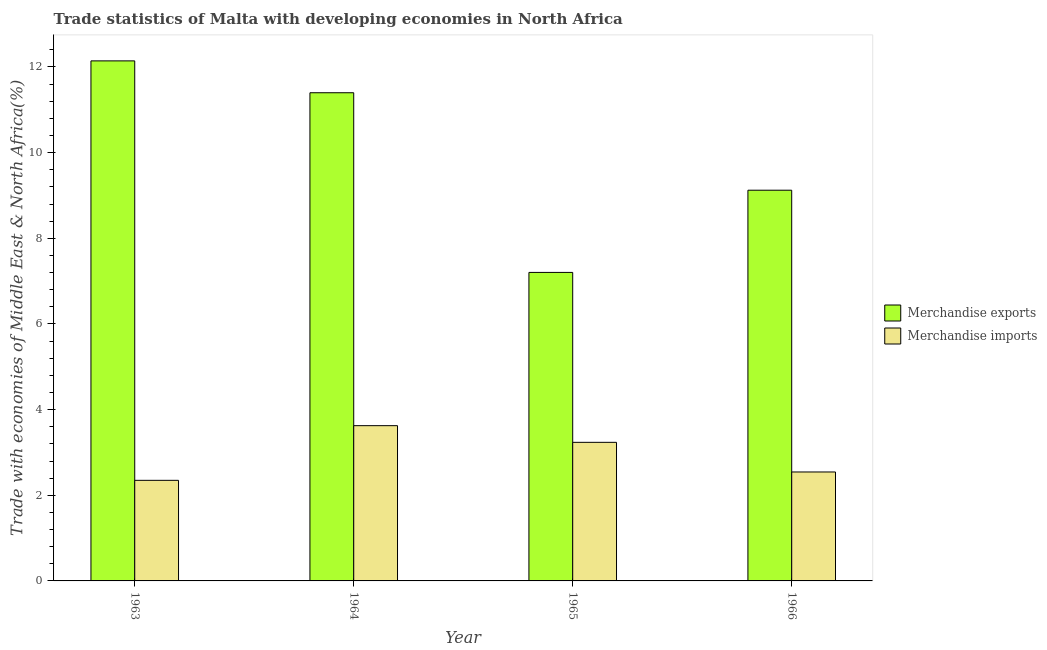How many different coloured bars are there?
Provide a succinct answer. 2. How many groups of bars are there?
Ensure brevity in your answer.  4. Are the number of bars per tick equal to the number of legend labels?
Your answer should be compact. Yes. Are the number of bars on each tick of the X-axis equal?
Offer a very short reply. Yes. How many bars are there on the 2nd tick from the right?
Give a very brief answer. 2. What is the label of the 2nd group of bars from the left?
Your answer should be compact. 1964. In how many cases, is the number of bars for a given year not equal to the number of legend labels?
Offer a very short reply. 0. What is the merchandise imports in 1965?
Offer a very short reply. 3.24. Across all years, what is the maximum merchandise imports?
Provide a short and direct response. 3.63. Across all years, what is the minimum merchandise imports?
Make the answer very short. 2.35. In which year was the merchandise imports maximum?
Your response must be concise. 1964. In which year was the merchandise exports minimum?
Your answer should be very brief. 1965. What is the total merchandise exports in the graph?
Your answer should be compact. 39.87. What is the difference between the merchandise imports in 1965 and that in 1966?
Make the answer very short. 0.69. What is the difference between the merchandise imports in 1965 and the merchandise exports in 1966?
Offer a terse response. 0.69. What is the average merchandise imports per year?
Ensure brevity in your answer.  2.94. In how many years, is the merchandise imports greater than 9.2 %?
Your response must be concise. 0. What is the ratio of the merchandise imports in 1965 to that in 1966?
Offer a terse response. 1.27. Is the difference between the merchandise exports in 1964 and 1966 greater than the difference between the merchandise imports in 1964 and 1966?
Your response must be concise. No. What is the difference between the highest and the second highest merchandise imports?
Your answer should be very brief. 0.39. What is the difference between the highest and the lowest merchandise imports?
Offer a very short reply. 1.28. In how many years, is the merchandise exports greater than the average merchandise exports taken over all years?
Offer a terse response. 2. Is the sum of the merchandise imports in 1964 and 1965 greater than the maximum merchandise exports across all years?
Give a very brief answer. Yes. What does the 2nd bar from the left in 1963 represents?
Ensure brevity in your answer.  Merchandise imports. How many bars are there?
Offer a terse response. 8. Are all the bars in the graph horizontal?
Offer a terse response. No. How many years are there in the graph?
Keep it short and to the point. 4. Does the graph contain any zero values?
Your response must be concise. No. Does the graph contain grids?
Your answer should be very brief. No. How many legend labels are there?
Offer a very short reply. 2. What is the title of the graph?
Your answer should be compact. Trade statistics of Malta with developing economies in North Africa. Does "Lower secondary education" appear as one of the legend labels in the graph?
Provide a short and direct response. No. What is the label or title of the Y-axis?
Your response must be concise. Trade with economies of Middle East & North Africa(%). What is the Trade with economies of Middle East & North Africa(%) in Merchandise exports in 1963?
Keep it short and to the point. 12.14. What is the Trade with economies of Middle East & North Africa(%) of Merchandise imports in 1963?
Keep it short and to the point. 2.35. What is the Trade with economies of Middle East & North Africa(%) in Merchandise exports in 1964?
Offer a terse response. 11.4. What is the Trade with economies of Middle East & North Africa(%) of Merchandise imports in 1964?
Provide a succinct answer. 3.63. What is the Trade with economies of Middle East & North Africa(%) in Merchandise exports in 1965?
Your answer should be very brief. 7.2. What is the Trade with economies of Middle East & North Africa(%) in Merchandise imports in 1965?
Provide a succinct answer. 3.24. What is the Trade with economies of Middle East & North Africa(%) in Merchandise exports in 1966?
Make the answer very short. 9.12. What is the Trade with economies of Middle East & North Africa(%) of Merchandise imports in 1966?
Make the answer very short. 2.54. Across all years, what is the maximum Trade with economies of Middle East & North Africa(%) of Merchandise exports?
Make the answer very short. 12.14. Across all years, what is the maximum Trade with economies of Middle East & North Africa(%) in Merchandise imports?
Give a very brief answer. 3.63. Across all years, what is the minimum Trade with economies of Middle East & North Africa(%) of Merchandise exports?
Offer a very short reply. 7.2. Across all years, what is the minimum Trade with economies of Middle East & North Africa(%) in Merchandise imports?
Offer a terse response. 2.35. What is the total Trade with economies of Middle East & North Africa(%) of Merchandise exports in the graph?
Offer a terse response. 39.87. What is the total Trade with economies of Middle East & North Africa(%) in Merchandise imports in the graph?
Give a very brief answer. 11.75. What is the difference between the Trade with economies of Middle East & North Africa(%) in Merchandise exports in 1963 and that in 1964?
Provide a succinct answer. 0.74. What is the difference between the Trade with economies of Middle East & North Africa(%) of Merchandise imports in 1963 and that in 1964?
Make the answer very short. -1.28. What is the difference between the Trade with economies of Middle East & North Africa(%) of Merchandise exports in 1963 and that in 1965?
Your response must be concise. 4.94. What is the difference between the Trade with economies of Middle East & North Africa(%) of Merchandise imports in 1963 and that in 1965?
Offer a terse response. -0.89. What is the difference between the Trade with economies of Middle East & North Africa(%) of Merchandise exports in 1963 and that in 1966?
Make the answer very short. 3.02. What is the difference between the Trade with economies of Middle East & North Africa(%) of Merchandise imports in 1963 and that in 1966?
Your answer should be very brief. -0.19. What is the difference between the Trade with economies of Middle East & North Africa(%) in Merchandise exports in 1964 and that in 1965?
Your response must be concise. 4.2. What is the difference between the Trade with economies of Middle East & North Africa(%) in Merchandise imports in 1964 and that in 1965?
Make the answer very short. 0.39. What is the difference between the Trade with economies of Middle East & North Africa(%) of Merchandise exports in 1964 and that in 1966?
Keep it short and to the point. 2.28. What is the difference between the Trade with economies of Middle East & North Africa(%) in Merchandise imports in 1964 and that in 1966?
Offer a very short reply. 1.08. What is the difference between the Trade with economies of Middle East & North Africa(%) in Merchandise exports in 1965 and that in 1966?
Offer a terse response. -1.92. What is the difference between the Trade with economies of Middle East & North Africa(%) in Merchandise imports in 1965 and that in 1966?
Keep it short and to the point. 0.69. What is the difference between the Trade with economies of Middle East & North Africa(%) in Merchandise exports in 1963 and the Trade with economies of Middle East & North Africa(%) in Merchandise imports in 1964?
Provide a short and direct response. 8.52. What is the difference between the Trade with economies of Middle East & North Africa(%) in Merchandise exports in 1963 and the Trade with economies of Middle East & North Africa(%) in Merchandise imports in 1965?
Give a very brief answer. 8.91. What is the difference between the Trade with economies of Middle East & North Africa(%) in Merchandise exports in 1963 and the Trade with economies of Middle East & North Africa(%) in Merchandise imports in 1966?
Offer a terse response. 9.6. What is the difference between the Trade with economies of Middle East & North Africa(%) of Merchandise exports in 1964 and the Trade with economies of Middle East & North Africa(%) of Merchandise imports in 1965?
Provide a succinct answer. 8.16. What is the difference between the Trade with economies of Middle East & North Africa(%) of Merchandise exports in 1964 and the Trade with economies of Middle East & North Africa(%) of Merchandise imports in 1966?
Offer a terse response. 8.86. What is the difference between the Trade with economies of Middle East & North Africa(%) of Merchandise exports in 1965 and the Trade with economies of Middle East & North Africa(%) of Merchandise imports in 1966?
Make the answer very short. 4.66. What is the average Trade with economies of Middle East & North Africa(%) of Merchandise exports per year?
Make the answer very short. 9.97. What is the average Trade with economies of Middle East & North Africa(%) of Merchandise imports per year?
Provide a succinct answer. 2.94. In the year 1963, what is the difference between the Trade with economies of Middle East & North Africa(%) of Merchandise exports and Trade with economies of Middle East & North Africa(%) of Merchandise imports?
Your response must be concise. 9.79. In the year 1964, what is the difference between the Trade with economies of Middle East & North Africa(%) in Merchandise exports and Trade with economies of Middle East & North Africa(%) in Merchandise imports?
Offer a very short reply. 7.77. In the year 1965, what is the difference between the Trade with economies of Middle East & North Africa(%) of Merchandise exports and Trade with economies of Middle East & North Africa(%) of Merchandise imports?
Offer a terse response. 3.97. In the year 1966, what is the difference between the Trade with economies of Middle East & North Africa(%) of Merchandise exports and Trade with economies of Middle East & North Africa(%) of Merchandise imports?
Your answer should be very brief. 6.58. What is the ratio of the Trade with economies of Middle East & North Africa(%) in Merchandise exports in 1963 to that in 1964?
Offer a very short reply. 1.07. What is the ratio of the Trade with economies of Middle East & North Africa(%) in Merchandise imports in 1963 to that in 1964?
Ensure brevity in your answer.  0.65. What is the ratio of the Trade with economies of Middle East & North Africa(%) of Merchandise exports in 1963 to that in 1965?
Offer a terse response. 1.69. What is the ratio of the Trade with economies of Middle East & North Africa(%) in Merchandise imports in 1963 to that in 1965?
Your response must be concise. 0.73. What is the ratio of the Trade with economies of Middle East & North Africa(%) of Merchandise exports in 1963 to that in 1966?
Give a very brief answer. 1.33. What is the ratio of the Trade with economies of Middle East & North Africa(%) of Merchandise imports in 1963 to that in 1966?
Give a very brief answer. 0.92. What is the ratio of the Trade with economies of Middle East & North Africa(%) of Merchandise exports in 1964 to that in 1965?
Your answer should be compact. 1.58. What is the ratio of the Trade with economies of Middle East & North Africa(%) of Merchandise imports in 1964 to that in 1965?
Your response must be concise. 1.12. What is the ratio of the Trade with economies of Middle East & North Africa(%) of Merchandise exports in 1964 to that in 1966?
Provide a short and direct response. 1.25. What is the ratio of the Trade with economies of Middle East & North Africa(%) in Merchandise imports in 1964 to that in 1966?
Make the answer very short. 1.43. What is the ratio of the Trade with economies of Middle East & North Africa(%) of Merchandise exports in 1965 to that in 1966?
Provide a short and direct response. 0.79. What is the ratio of the Trade with economies of Middle East & North Africa(%) in Merchandise imports in 1965 to that in 1966?
Your answer should be very brief. 1.27. What is the difference between the highest and the second highest Trade with economies of Middle East & North Africa(%) of Merchandise exports?
Your answer should be very brief. 0.74. What is the difference between the highest and the second highest Trade with economies of Middle East & North Africa(%) of Merchandise imports?
Provide a short and direct response. 0.39. What is the difference between the highest and the lowest Trade with economies of Middle East & North Africa(%) in Merchandise exports?
Keep it short and to the point. 4.94. What is the difference between the highest and the lowest Trade with economies of Middle East & North Africa(%) of Merchandise imports?
Your response must be concise. 1.28. 